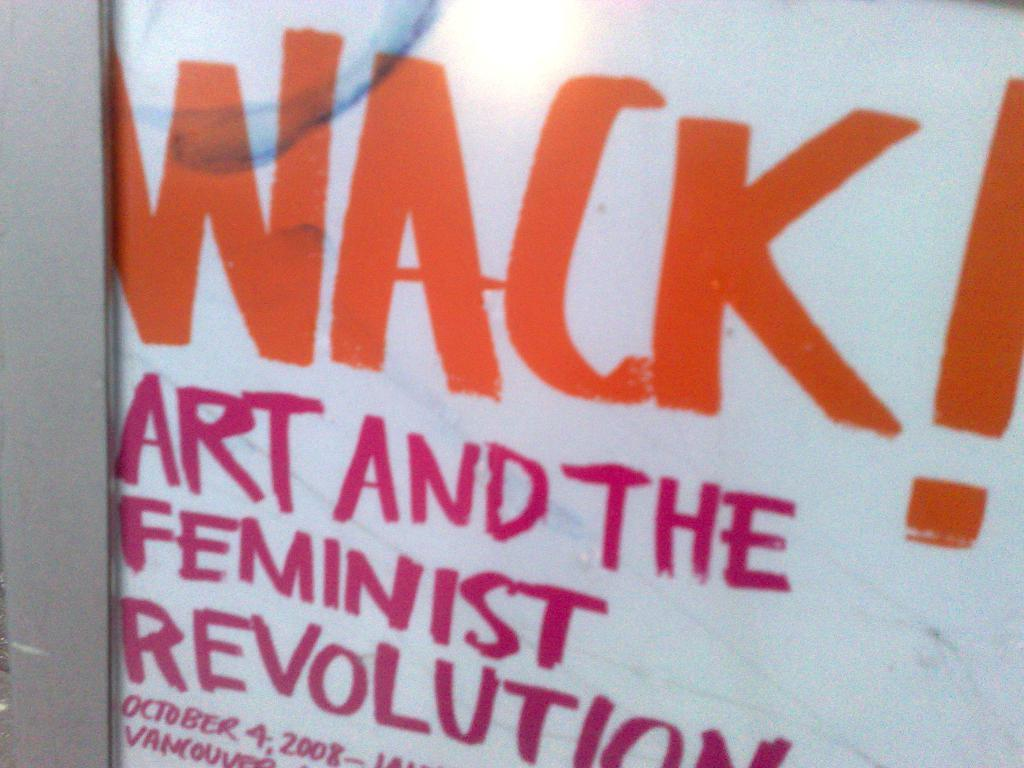<image>
Relay a brief, clear account of the picture shown. A poster about Art and the Feminist Revolution. 